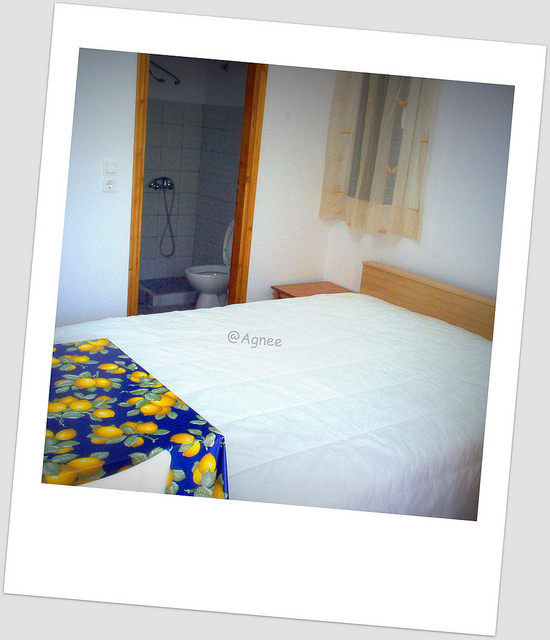Please transcribe the text information in this image. Agnee @ 